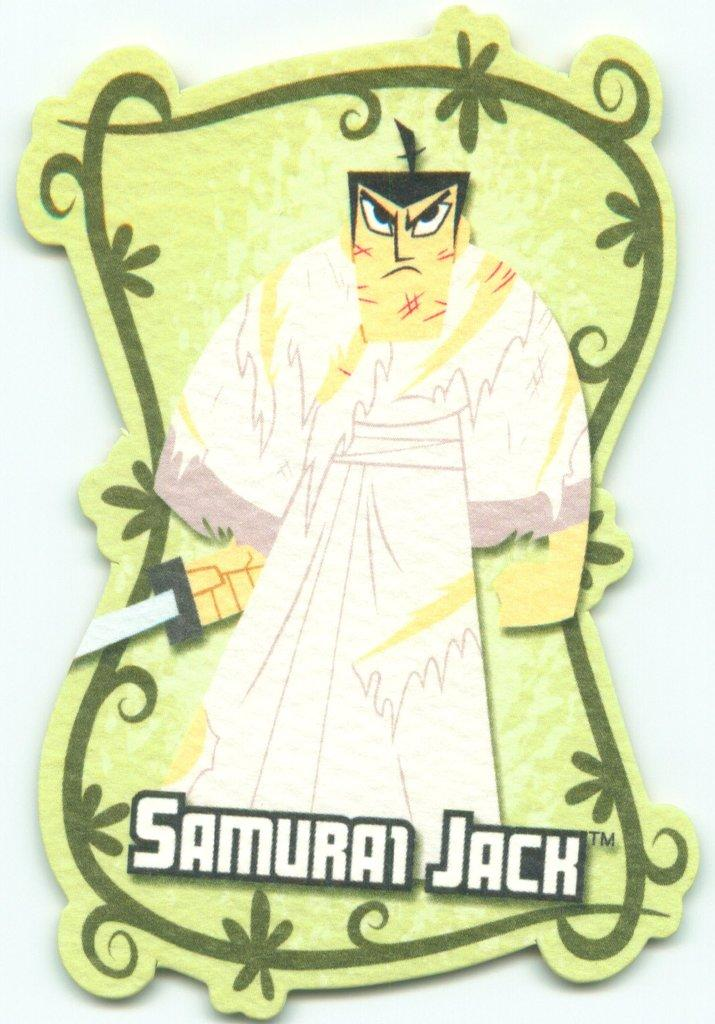What is present in the image that has an image and text? There is a poster in the image that has an image and text. Can you describe the image on the poster? The provided facts do not give information about the image on the poster, so we cannot describe it. What type of text is written on the poster? The provided facts do not give information about the type of text on the poster, so we cannot describe it. How many grapes are on the floor next to the poster in the image? There is no mention of grapes or a floor in the provided facts, so we cannot answer this question. 